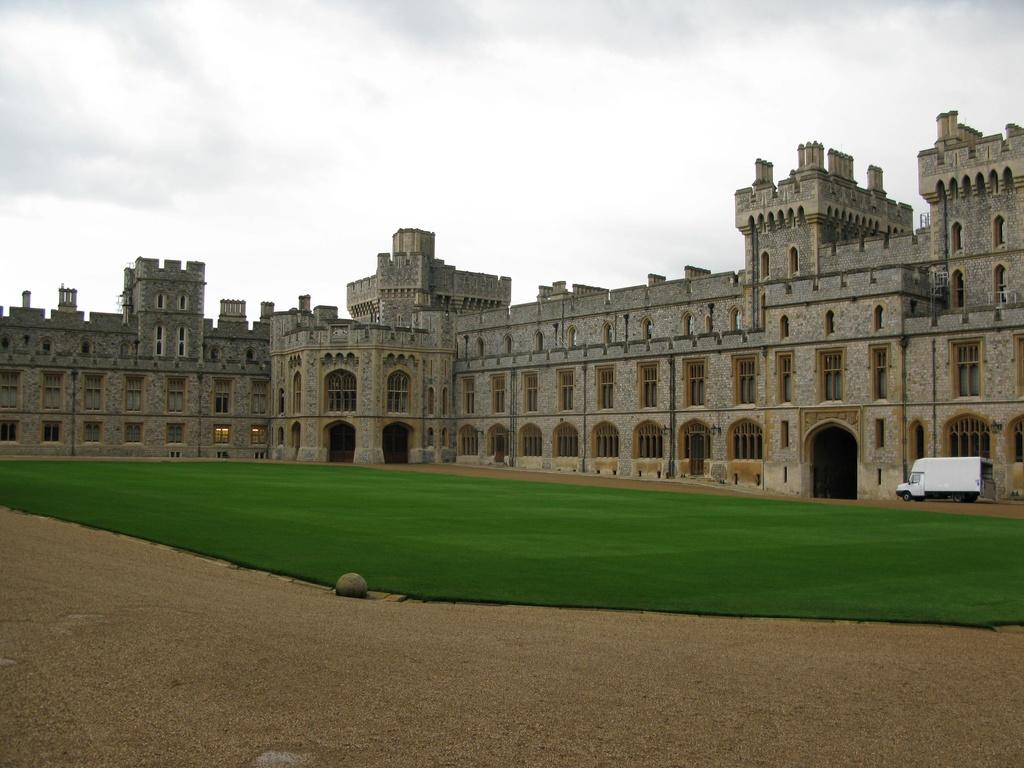What type of structure is depicted in the image? The image appears to be a fort. What architectural features can be seen on the fort? There are windows in the fort. What else is visible in the right corner of the image? There is a vehicle in the right corner of the image. What type of vegetation is present in the image? There is grass in the image. What is visible at the bottom of the image? The ground is visible at the bottom of the image. What is visible at the top of the image? The sky is visible at the top of the image. What type of prose can be seen in the garden near the fort? There is no prose or garden present in the image; it features a fort with windows, a vehicle, grass, ground, and sky. 